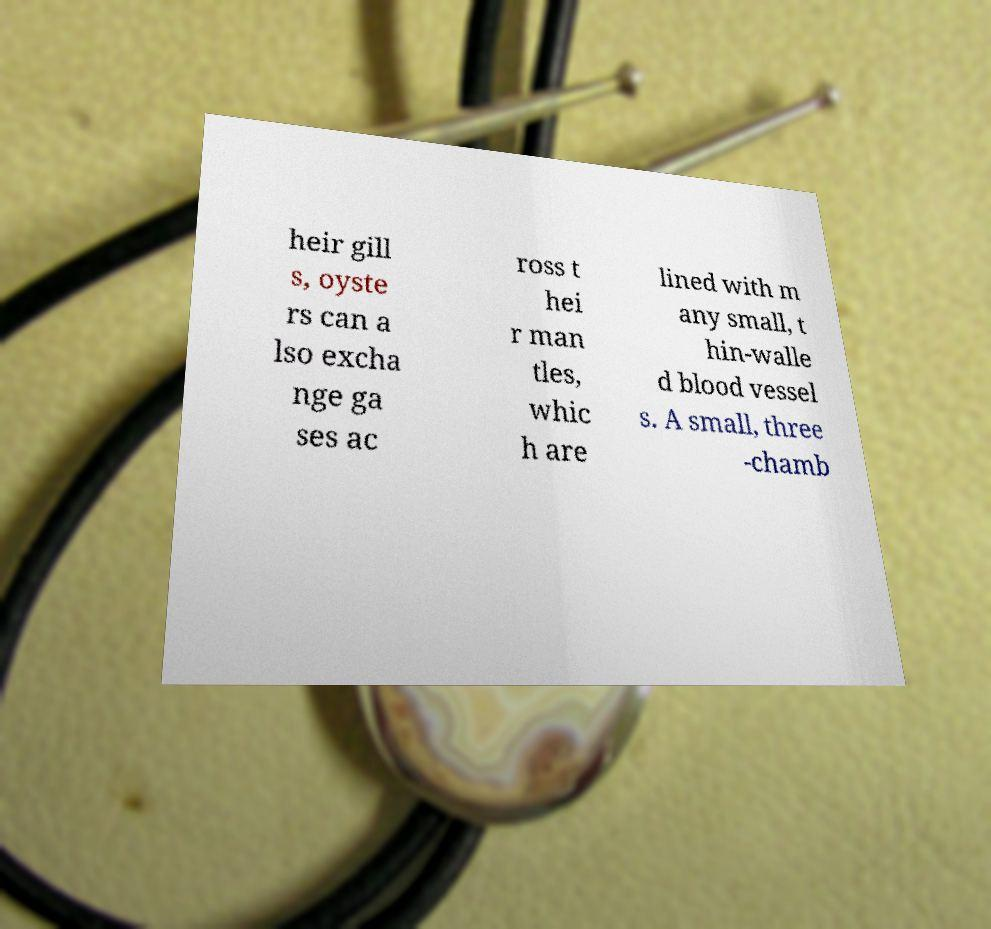Could you assist in decoding the text presented in this image and type it out clearly? heir gill s, oyste rs can a lso excha nge ga ses ac ross t hei r man tles, whic h are lined with m any small, t hin-walle d blood vessel s. A small, three -chamb 